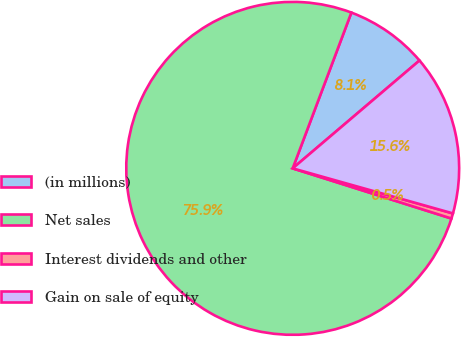<chart> <loc_0><loc_0><loc_500><loc_500><pie_chart><fcel>(in millions)<fcel>Net sales<fcel>Interest dividends and other<fcel>Gain on sale of equity<nl><fcel>8.05%<fcel>75.86%<fcel>0.51%<fcel>15.58%<nl></chart> 